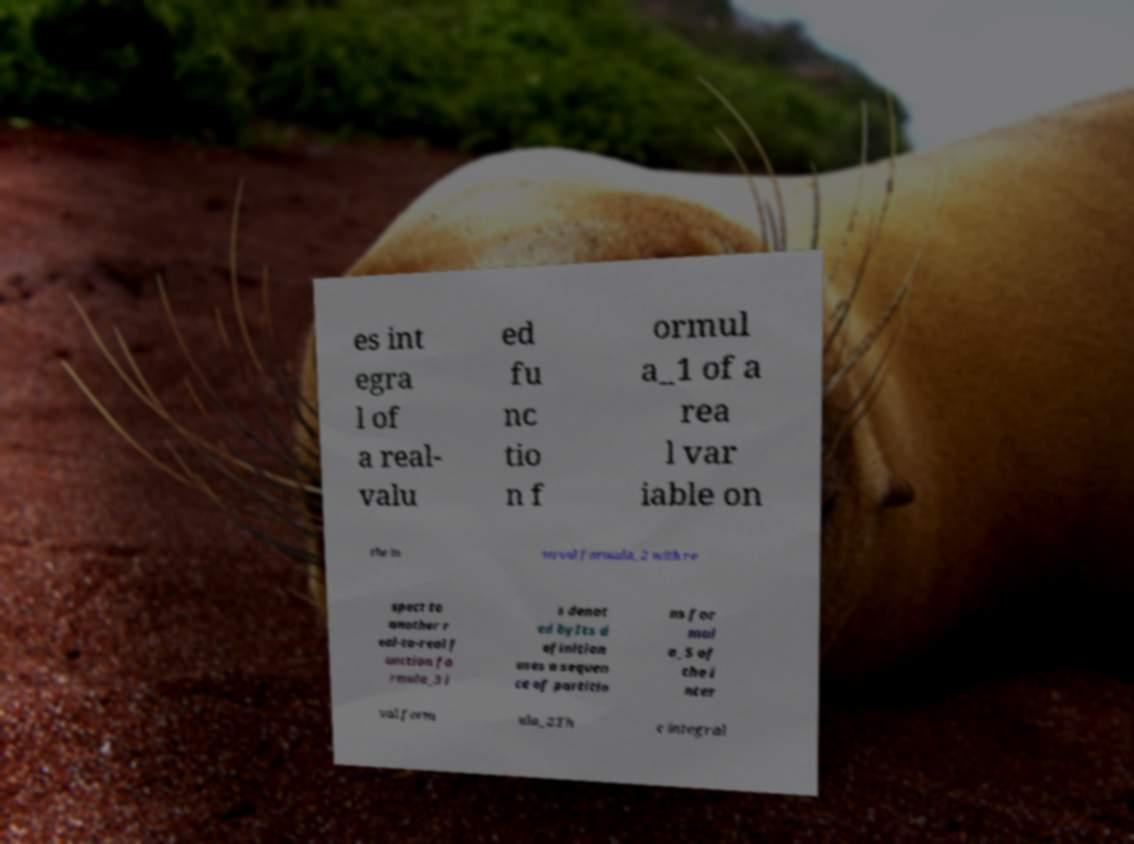There's text embedded in this image that I need extracted. Can you transcribe it verbatim? es int egra l of a real- valu ed fu nc tio n f ormul a_1 of a rea l var iable on the in terval formula_2 with re spect to another r eal-to-real f unction fo rmula_3 i s denot ed byIts d efinition uses a sequen ce of partitio ns for mul a_5 of the i nter val form ula_2Th e integral 